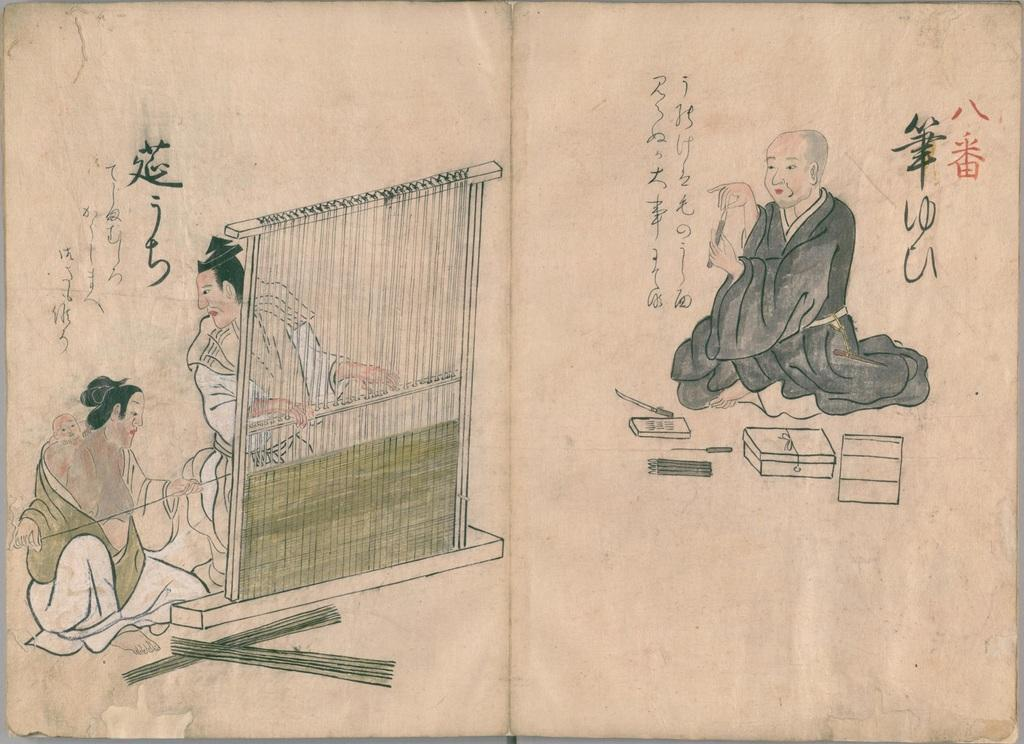What medium is used for the artwork in the image? The image is a painting on paper. Can you describe the man's position in the painting? The man is sitting on the right side of the painting. How many men are present in the painting? There are two men in the painting. Where are the two men located in the painting? The two men are on the left side of the painting. What additional elements can be seen in the painting? There are threads visible in the painting. What type of baby is depicted in the painting? There is no baby present in the painting; it features two men and threads. What flavor of eggnog is being consumed by the men in the painting? There is no eggnog present in the painting; it is a painting of two men and threads. 